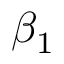Convert formula to latex. <formula><loc_0><loc_0><loc_500><loc_500>\beta _ { 1 }</formula> 